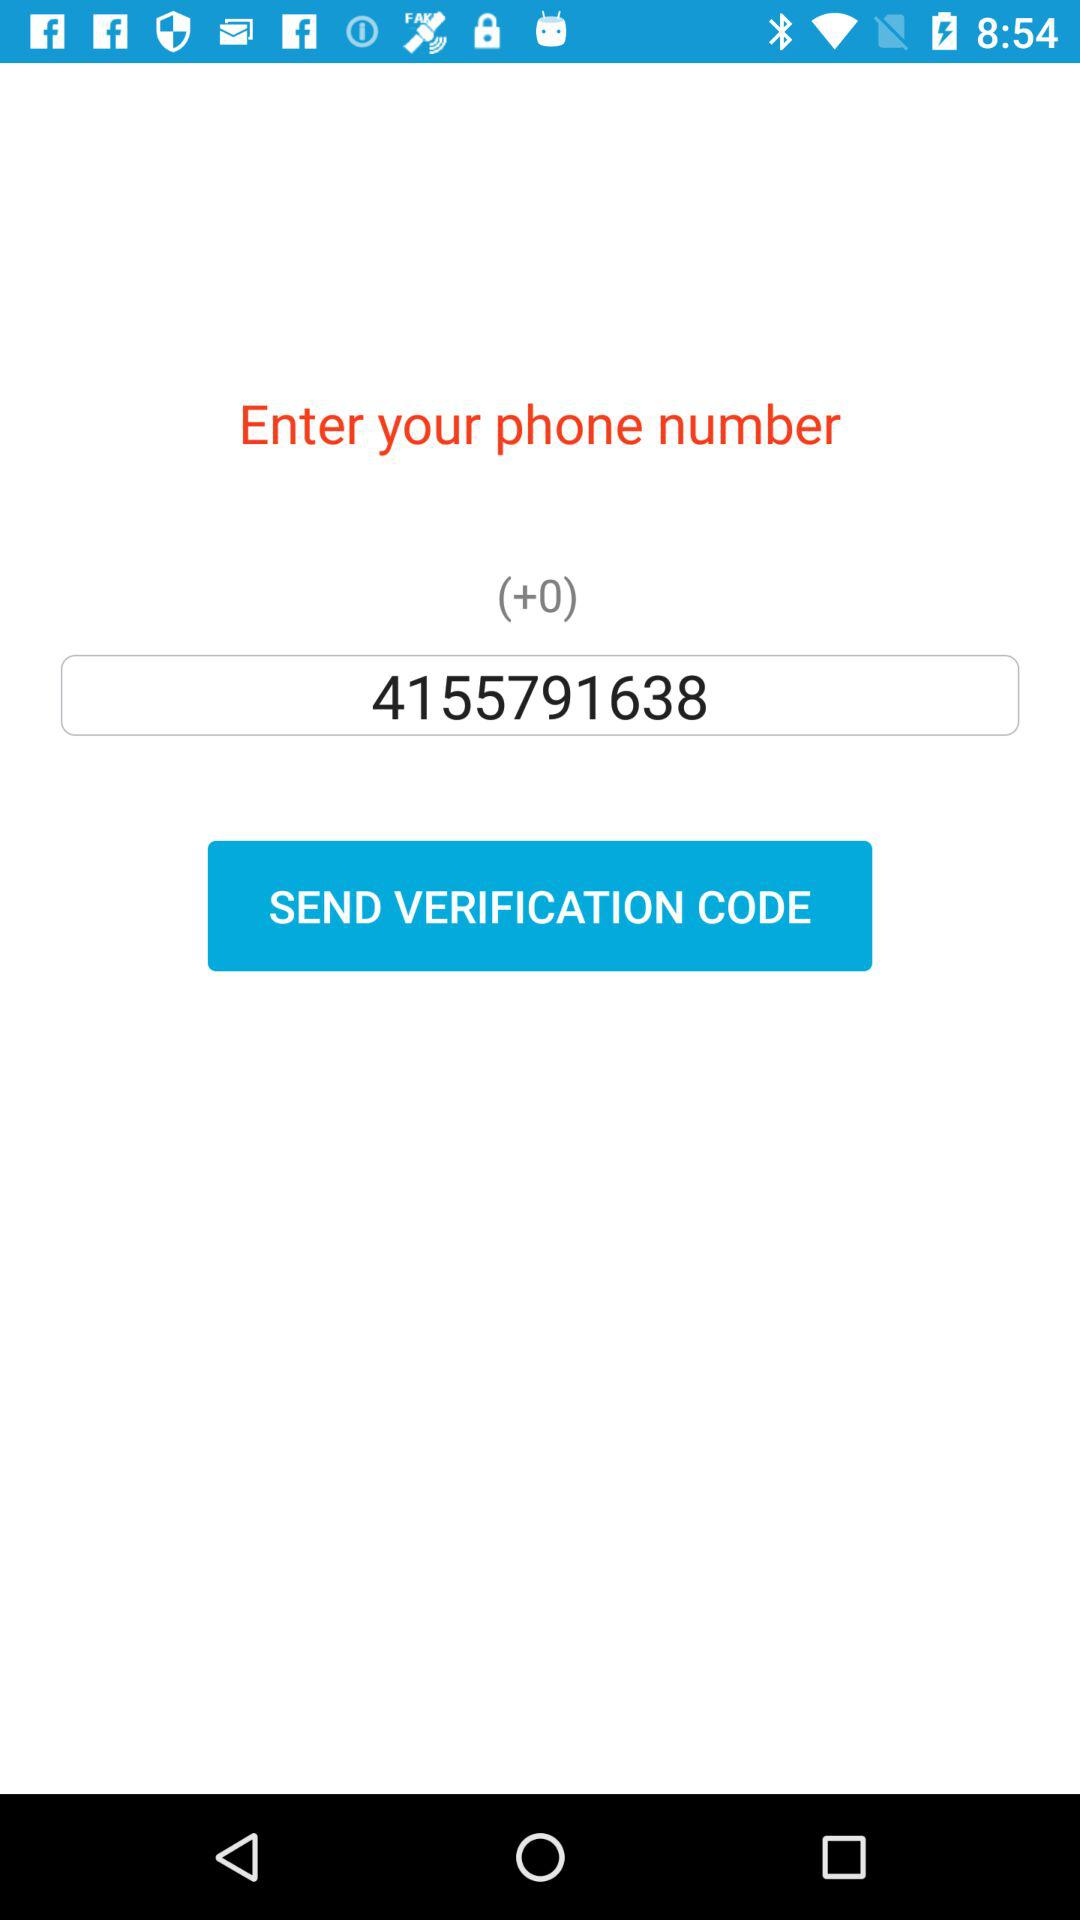What is the given phone number? The given phone number is 4155791638. 